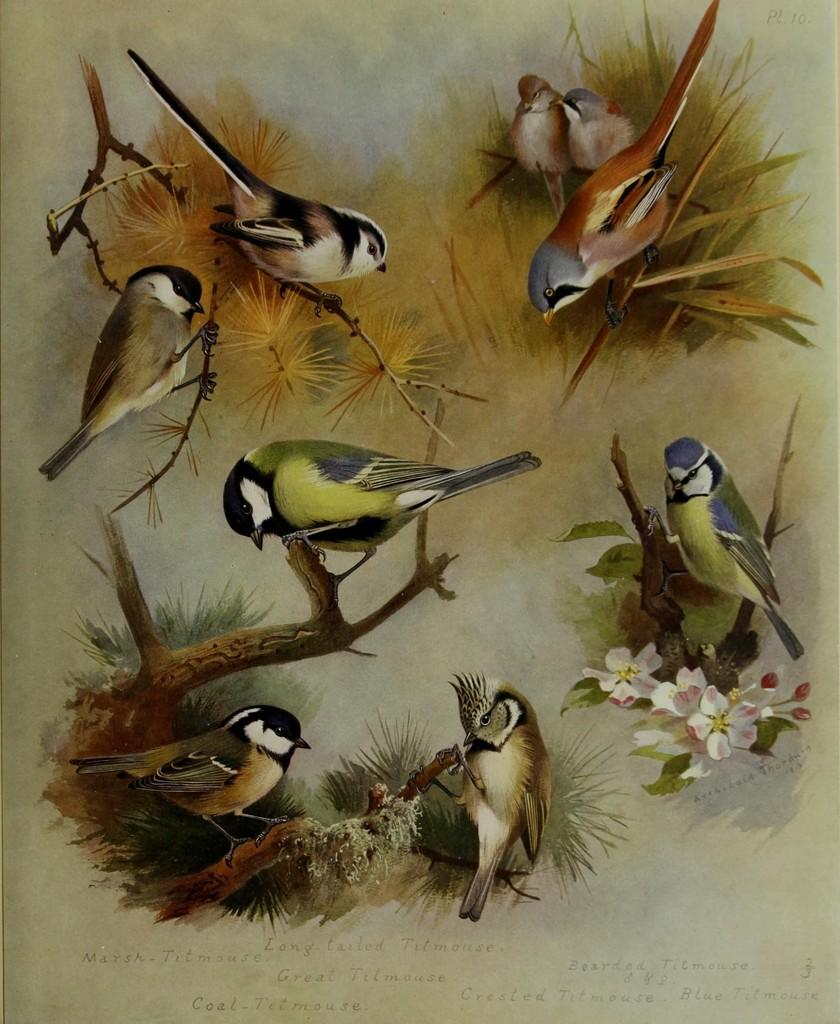What is the main subject of the image? The main subject of the image is a page. What can be found on the page? There are different types of birds on the page. What type of wire is used to hold the birds in the image? There is no wire present in the image; the birds are depicted on a page. 